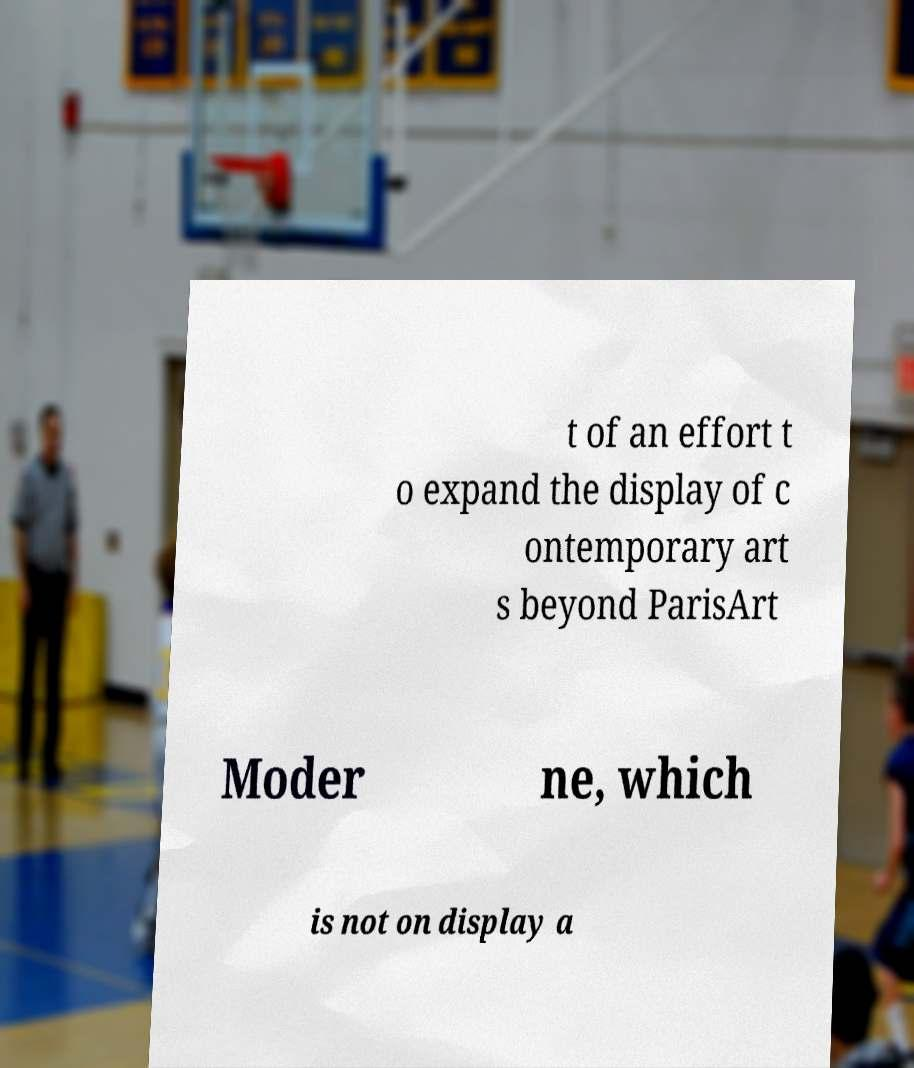Could you extract and type out the text from this image? t of an effort t o expand the display of c ontemporary art s beyond ParisArt Moder ne, which is not on display a 